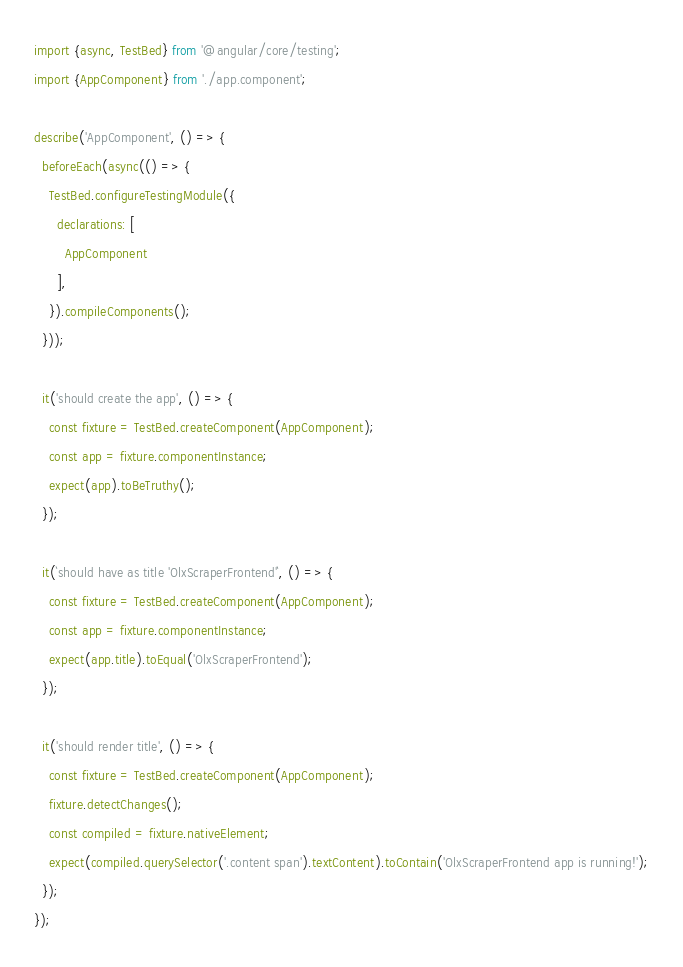Convert code to text. <code><loc_0><loc_0><loc_500><loc_500><_TypeScript_>import {async, TestBed} from '@angular/core/testing';
import {AppComponent} from './app.component';

describe('AppComponent', () => {
  beforeEach(async(() => {
    TestBed.configureTestingModule({
      declarations: [
        AppComponent
      ],
    }).compileComponents();
  }));

  it('should create the app', () => {
    const fixture = TestBed.createComponent(AppComponent);
    const app = fixture.componentInstance;
    expect(app).toBeTruthy();
  });

  it(`should have as title 'OlxScraperFrontend'`, () => {
    const fixture = TestBed.createComponent(AppComponent);
    const app = fixture.componentInstance;
    expect(app.title).toEqual('OlxScraperFrontend');
  });

  it('should render title', () => {
    const fixture = TestBed.createComponent(AppComponent);
    fixture.detectChanges();
    const compiled = fixture.nativeElement;
    expect(compiled.querySelector('.content span').textContent).toContain('OlxScraperFrontend app is running!');
  });
});
</code> 